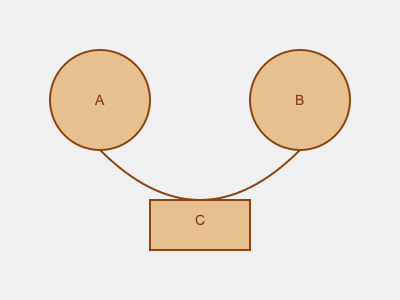Which combination of wooden toy parts would create the most whimsical creature when assembled? To determine the most whimsical creature combination, let's analyze each part:

1. Part A: A circular shape, likely representing a head or body.
2. Part B: Another circular shape, similar to A, could be a second head or body.
3. Part C: A rectangular shape, possibly representing a body or platform.
4. The curved line connecting A and B suggests a potential connection or movement between these parts.

Now, let's consider the combinations:

1. A + B: Two circular parts could create a creature with two heads or a head and body, which is quite whimsical.
2. A + C or B + C: A circular part with a rectangular part could form a more traditional body shape, less whimsical.
3. A + B + C: Combining all three parts would create the most complex and potentially whimsical creature.

The most whimsical combination would likely incorporate all three parts (A + B + C) because:

1. It uses all available elements, maximizing creative potential.
2. The contrast between circular and rectangular shapes adds visual interest.
3. The curved line suggests a playful connection between the circular parts, which can be further enhanced by the rectangular base.

This combination allows for various interpretations, such as:
- A two-headed creature standing on a platform
- A creature with a head, body, and tail or appendage
- An abstract being with multiple body parts

The versatility and unexpected combination of shapes make A + B + C the most conducive to creating a whimsical creature in mixed-media artwork.
Answer: A + B + C 